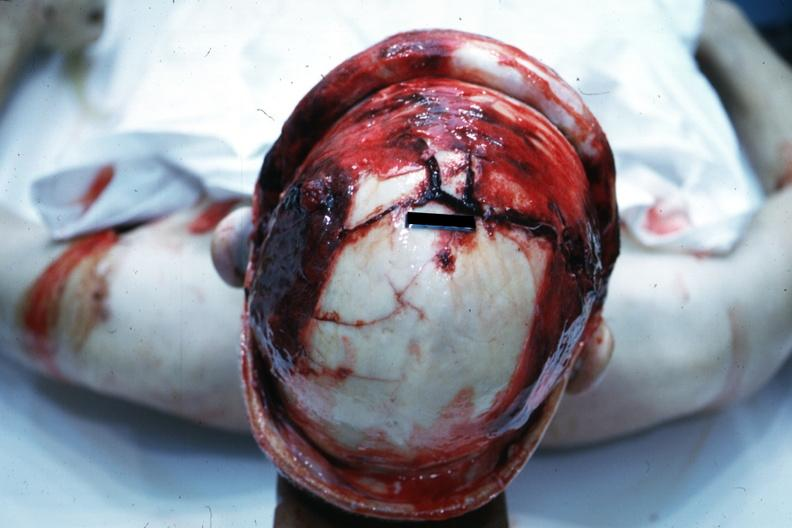what is view of head with scalp retracted?
Answer the question using a single word or phrase. To show massive fractures 